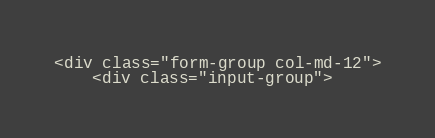<code> <loc_0><loc_0><loc_500><loc_500><_PHP_><div class="form-group col-md-12">
    <div class="input-group"></code> 